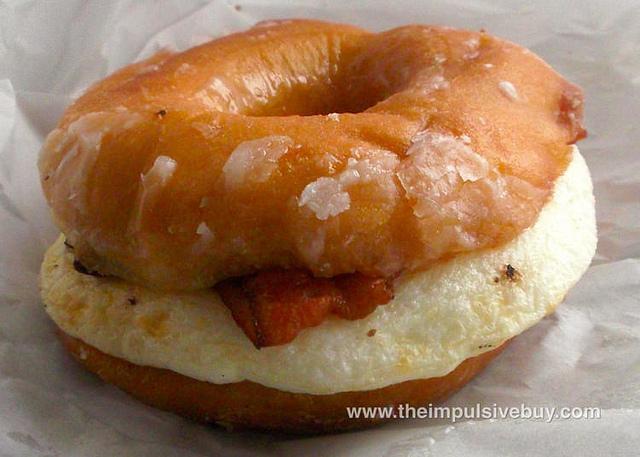How many people are wearing eyeglasses at the table?
Give a very brief answer. 0. 